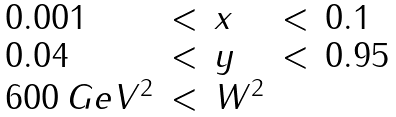Convert formula to latex. <formula><loc_0><loc_0><loc_500><loc_500>\begin{array} { l l l l l } { 0 . 0 0 1 } & { < } & { x } & { < } & { 0 . 1 } \\ { 0 . 0 4 } & { < } & { y } & { < } & { 0 . 9 5 } \\ { { 6 0 0 \, G e V ^ { 2 } } } & { < } & { { W ^ { 2 } } } \end{array}</formula> 